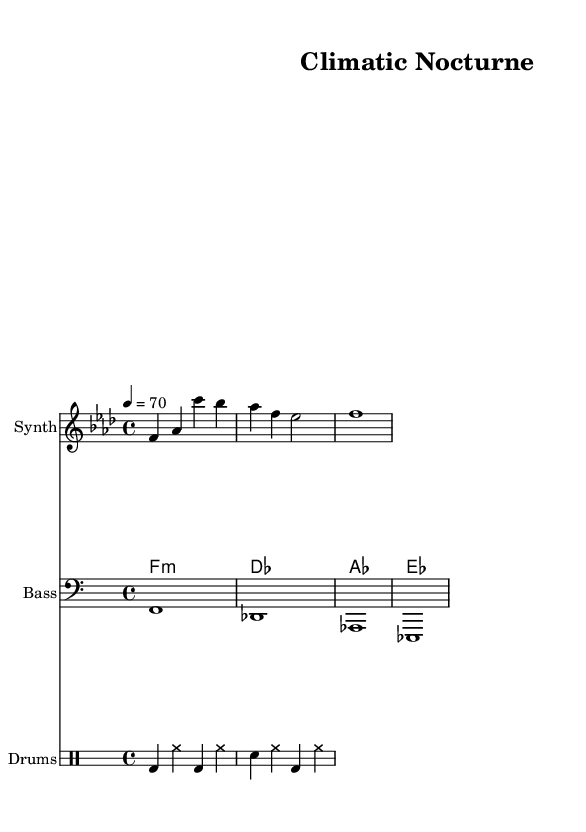What is the key signature of this music? The key signature is F minor, which has four flats: B flat, E flat, A flat, and D flat, as indicated by the key signature at the beginning of the staff.
Answer: F minor What is the time signature of this piece? The time signature is presented as 4/4, which means there are four beats in each measure and the quarter note gets one beat. This is noted at the beginning of the score.
Answer: 4/4 What is the tempo marking? The tempo marking shows "4 = 70," indicating a moderate tempo of 70 beats per minute, which is noted directly above the musical staff.
Answer: 70 How many measures are in the melody? The melody part has three measures as counted visually, with the measures separated by vertical bar lines. Counting these, we find three distinct measures.
Answer: 3 What type of synthesis instrument is indicated in the score? The instrument specified for the melody part is a Synth, as indicated at the beginning of the corresponding staff. This is reflective of typical electronic music instrumentation.
Answer: Synth Which drum elements are used in the drum pattern? The drum pattern includes bass drum and snare drum, indicated by their respective standard drum notation symbols in the drum staff section. The bass drum (bd) and snare (sn) are identified in the score structure as the primary components.
Answer: Bass drum and snare drum What overall genre does this piece represent? The piece is categorized as electronic music, specifically atmospheric downtempo, which is characterized by its chill beats and soundscapes, making it suitable for study sessions. This style is evident through the synth, harmony, and rhythm choices.
Answer: Electronic 